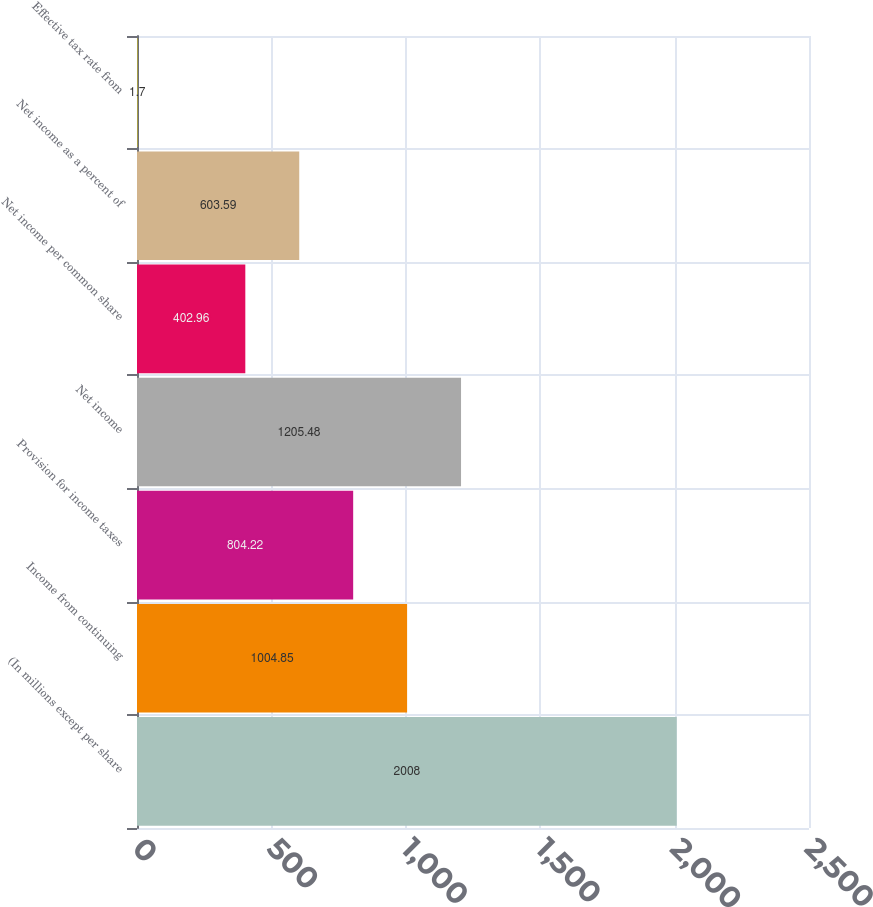<chart> <loc_0><loc_0><loc_500><loc_500><bar_chart><fcel>(In millions except per share<fcel>Income from continuing<fcel>Provision for income taxes<fcel>Net income<fcel>Net income per common share<fcel>Net income as a percent of<fcel>Effective tax rate from<nl><fcel>2008<fcel>1004.85<fcel>804.22<fcel>1205.48<fcel>402.96<fcel>603.59<fcel>1.7<nl></chart> 